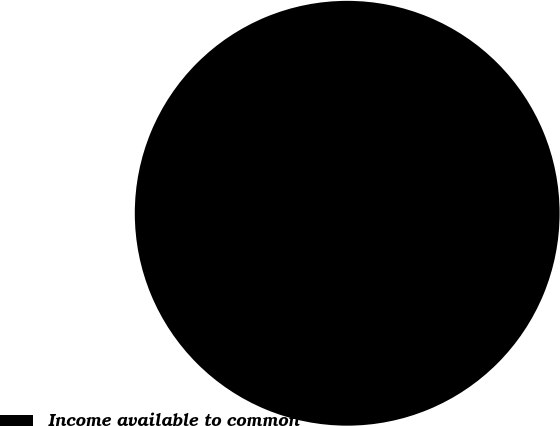Convert chart. <chart><loc_0><loc_0><loc_500><loc_500><pie_chart><fcel>Income available to common<nl><fcel>100.0%<nl></chart> 